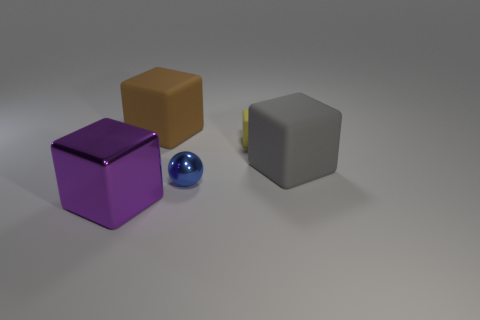Add 5 tiny blue cubes. How many objects exist? 10 Subtract all large blocks. How many blocks are left? 1 Subtract all yellow blocks. How many blocks are left? 3 Subtract 1 spheres. How many spheres are left? 0 Subtract all big gray cubes. Subtract all tiny yellow blocks. How many objects are left? 3 Add 5 gray matte blocks. How many gray matte blocks are left? 6 Add 5 purple objects. How many purple objects exist? 6 Subtract 0 purple cylinders. How many objects are left? 5 Subtract all cubes. How many objects are left? 1 Subtract all green blocks. Subtract all yellow spheres. How many blocks are left? 4 